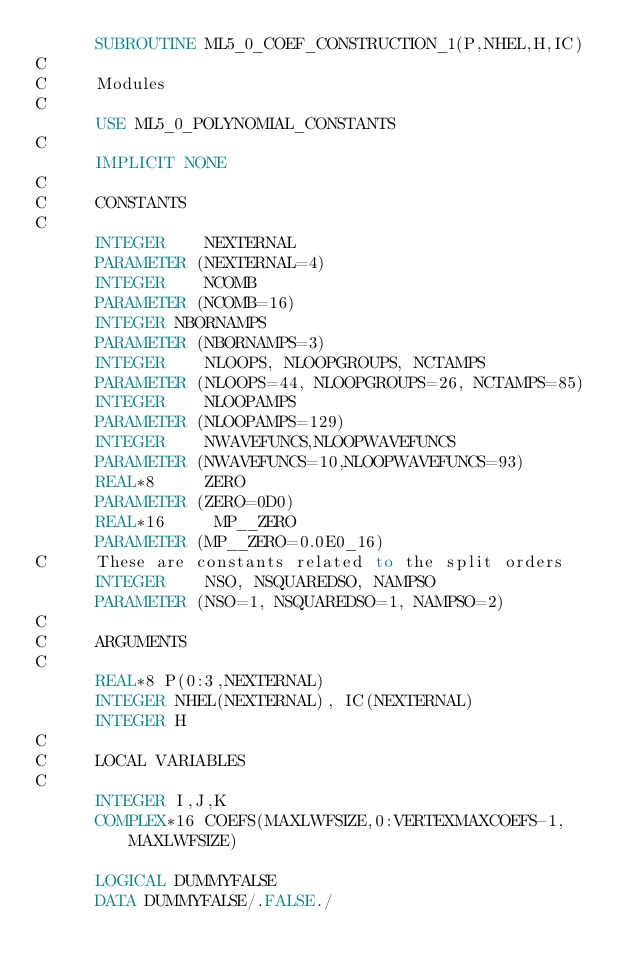<code> <loc_0><loc_0><loc_500><loc_500><_FORTRAN_>      SUBROUTINE ML5_0_COEF_CONSTRUCTION_1(P,NHEL,H,IC)
C     
C     Modules
C     
      USE ML5_0_POLYNOMIAL_CONSTANTS
C     
      IMPLICIT NONE
C     
C     CONSTANTS
C     
      INTEGER    NEXTERNAL
      PARAMETER (NEXTERNAL=4)
      INTEGER    NCOMB
      PARAMETER (NCOMB=16)
      INTEGER NBORNAMPS
      PARAMETER (NBORNAMPS=3)
      INTEGER    NLOOPS, NLOOPGROUPS, NCTAMPS
      PARAMETER (NLOOPS=44, NLOOPGROUPS=26, NCTAMPS=85)
      INTEGER    NLOOPAMPS
      PARAMETER (NLOOPAMPS=129)
      INTEGER    NWAVEFUNCS,NLOOPWAVEFUNCS
      PARAMETER (NWAVEFUNCS=10,NLOOPWAVEFUNCS=93)
      REAL*8     ZERO
      PARAMETER (ZERO=0D0)
      REAL*16     MP__ZERO
      PARAMETER (MP__ZERO=0.0E0_16)
C     These are constants related to the split orders
      INTEGER    NSO, NSQUAREDSO, NAMPSO
      PARAMETER (NSO=1, NSQUAREDSO=1, NAMPSO=2)
C     
C     ARGUMENTS
C     
      REAL*8 P(0:3,NEXTERNAL)
      INTEGER NHEL(NEXTERNAL), IC(NEXTERNAL)
      INTEGER H
C     
C     LOCAL VARIABLES
C     
      INTEGER I,J,K
      COMPLEX*16 COEFS(MAXLWFSIZE,0:VERTEXMAXCOEFS-1,MAXLWFSIZE)

      LOGICAL DUMMYFALSE
      DATA DUMMYFALSE/.FALSE./</code> 